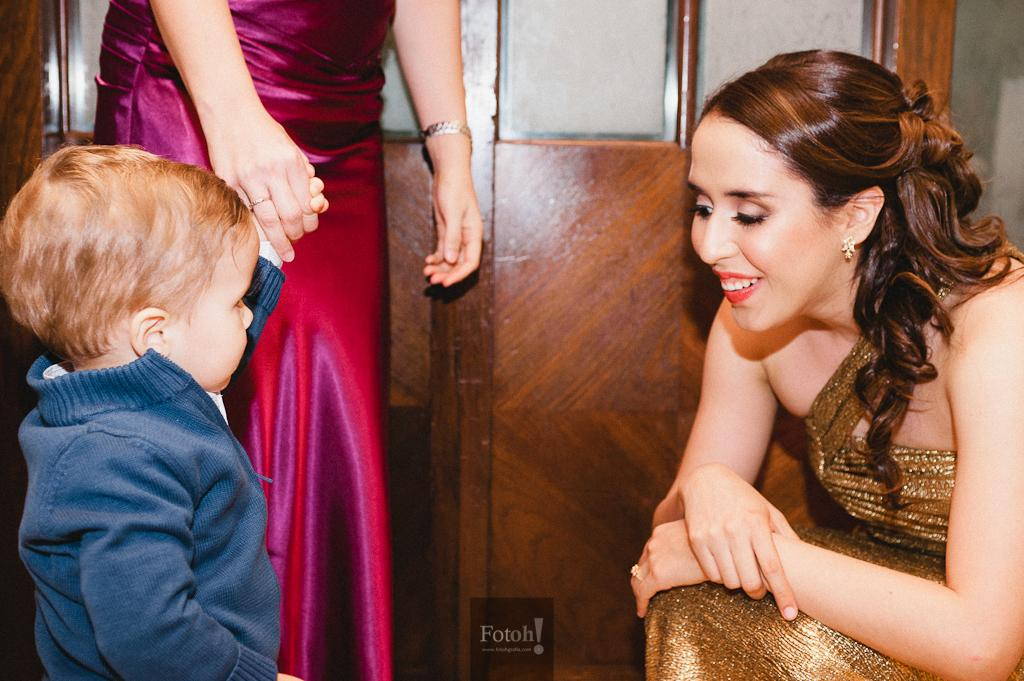What is the main subject of the image? The main subject of the image is a boy. Can you describe the boy's clothing in the image? The boy is wearing a blue jacket in the image. Who else can be seen in the image besides the boy? There is a person standing near a wall and a woman in the image. What type of behavior does the toad exhibit in the image? There is no toad present in the image, so it is not possible to determine its behavior. 